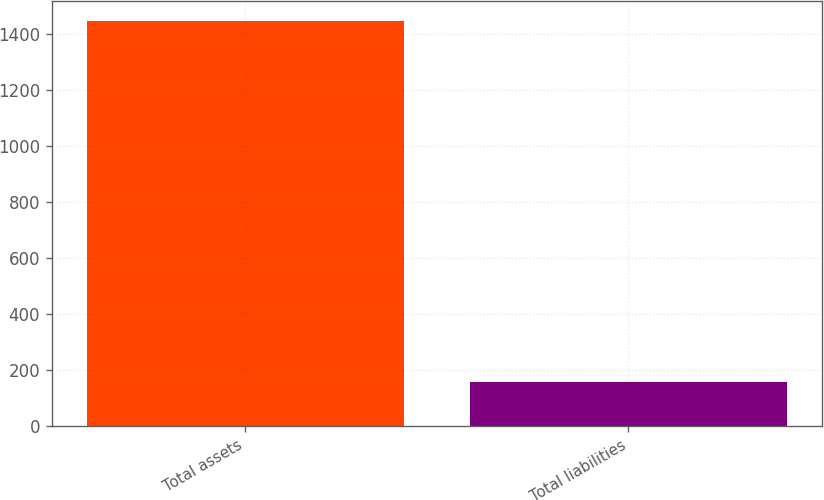Convert chart to OTSL. <chart><loc_0><loc_0><loc_500><loc_500><bar_chart><fcel>Total assets<fcel>Total liabilities<nl><fcel>1447<fcel>160<nl></chart> 